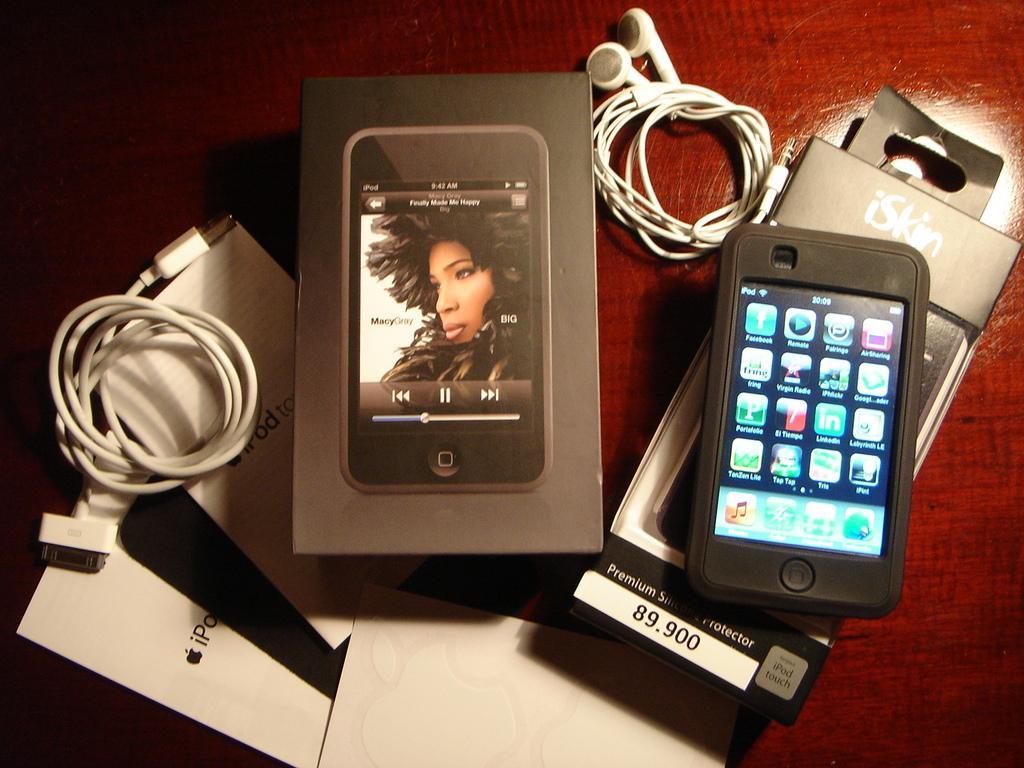Please provide a concise description of this image. In this image we can see a cell phone, headset, wire, a few papers, a box on a surface which looks like a table. 